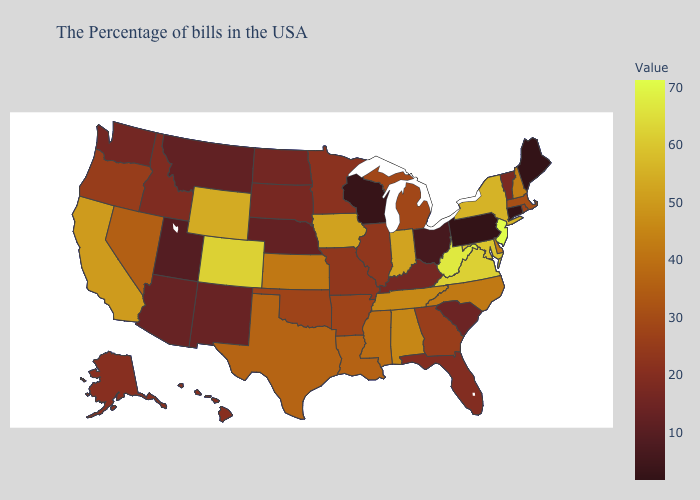Among the states that border New Mexico , does Utah have the highest value?
Answer briefly. No. Among the states that border Nevada , which have the lowest value?
Short answer required. Utah. Among the states that border Utah , which have the lowest value?
Write a very short answer. Arizona. Which states have the lowest value in the USA?
Keep it brief. Maine, Connecticut, Pennsylvania. Which states have the lowest value in the South?
Short answer required. South Carolina. Does the map have missing data?
Answer briefly. No. Does Wisconsin have the highest value in the MidWest?
Give a very brief answer. No. 